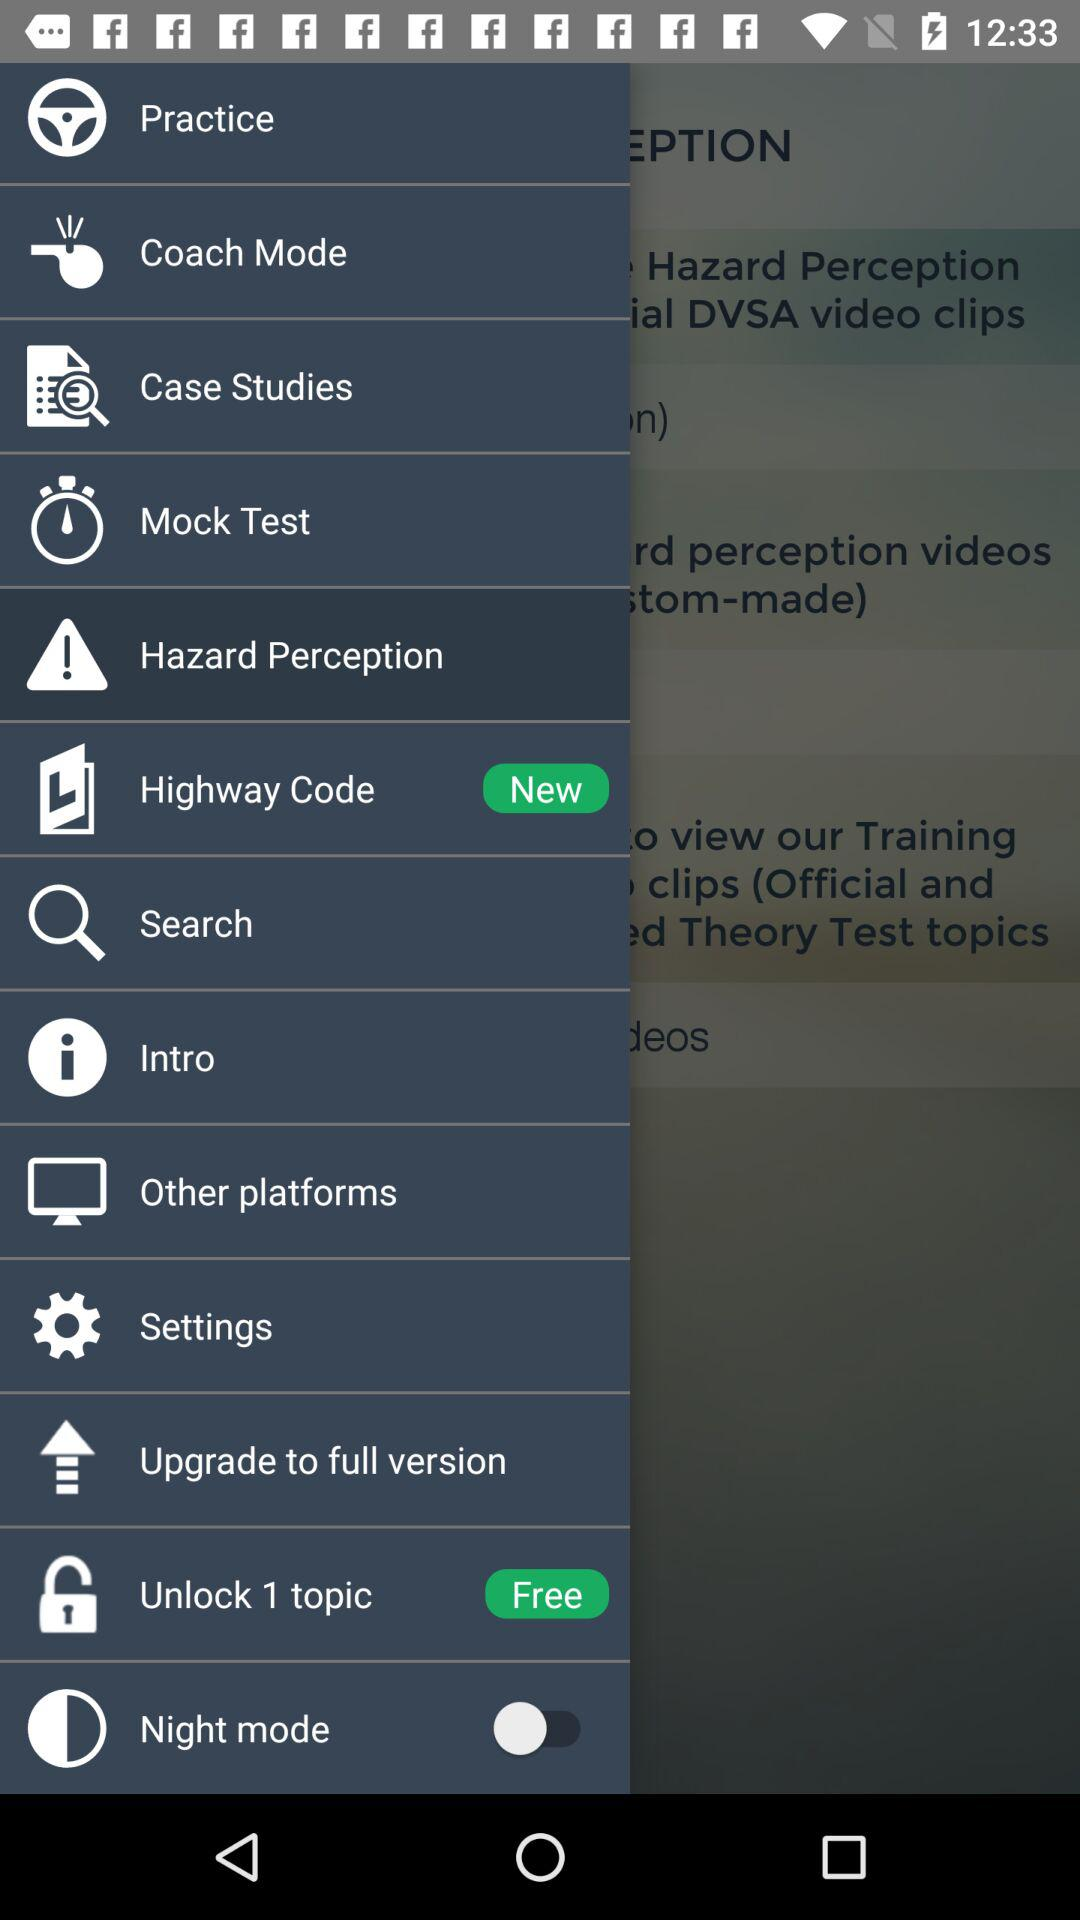What is the status of "Night mode"? The status is "off". 